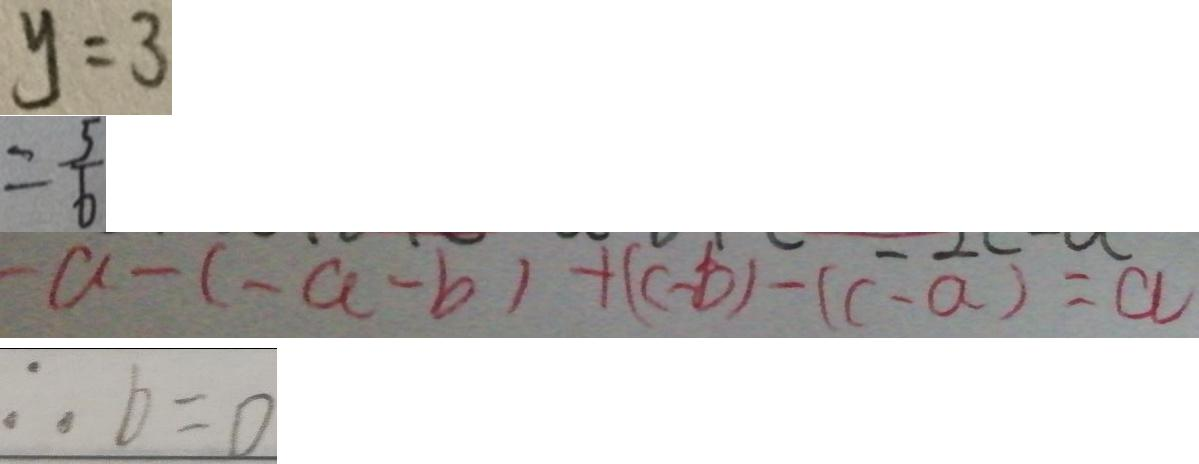<formula> <loc_0><loc_0><loc_500><loc_500>y = 3 
 = \frac { 5 } { 6 } 
 - a - ( - a - b ) + ( c - b ) - ( c - a ) = a 
 \therefore b = 0</formula> 